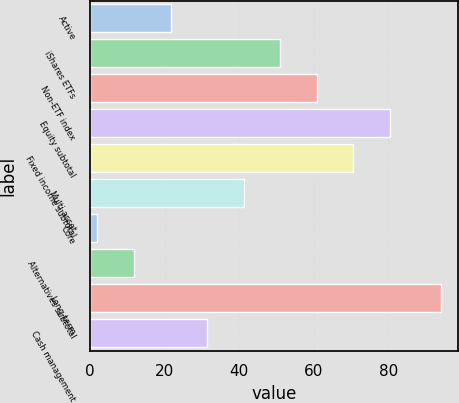<chart> <loc_0><loc_0><loc_500><loc_500><bar_chart><fcel>Active<fcel>iShares ETFs<fcel>Non-ETF index<fcel>Equity subtotal<fcel>Fixed income subtotal<fcel>Multi-asset<fcel>Core<fcel>Alternatives subtotal<fcel>Long-term<fcel>Cash management<nl><fcel>21.6<fcel>51<fcel>60.8<fcel>80.4<fcel>70.6<fcel>41.2<fcel>2<fcel>11.8<fcel>94<fcel>31.4<nl></chart> 